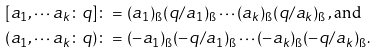<formula> <loc_0><loc_0><loc_500><loc_500>[ a _ { 1 } , \cdots a _ { k } \colon q ] & \colon = ( a _ { 1 } ) _ { \i } ( q / a _ { 1 } ) _ { \i } \cdots ( a _ { k } ) _ { \i } ( q / a _ { k } ) _ { \i } \, , \text {and} \\ ( a _ { 1 } , \cdots a _ { k } \colon q ) & \colon = ( - a _ { 1 } ) _ { \i } ( - q / a _ { 1 } ) _ { \i } \cdots ( - a _ { k } ) _ { \i } ( - q / a _ { k } ) _ { \i } .</formula> 